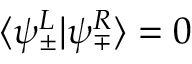<formula> <loc_0><loc_0><loc_500><loc_500>\langle \psi _ { \pm } ^ { L } | \psi _ { \mp } ^ { R } \rangle = 0</formula> 